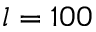<formula> <loc_0><loc_0><loc_500><loc_500>l = 1 0 0</formula> 